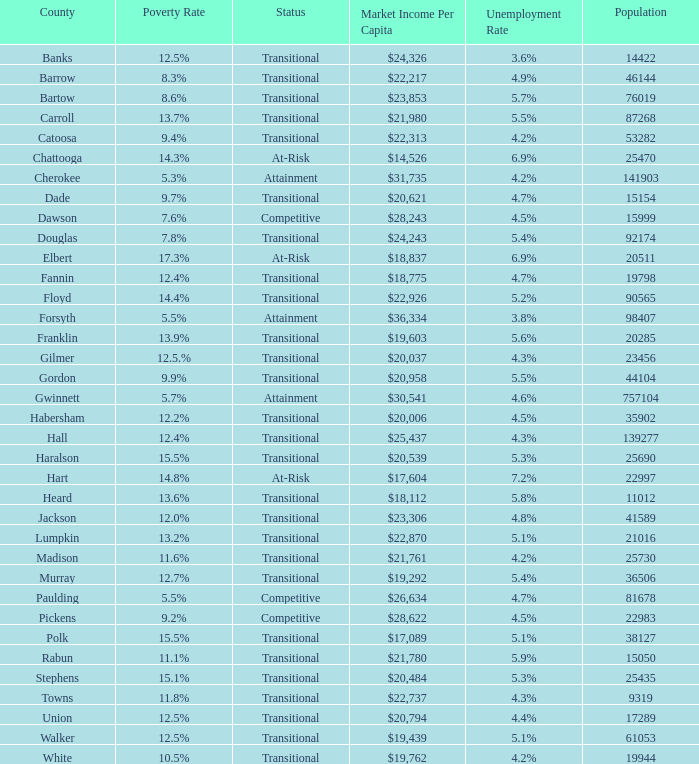What is the unemployment rate for the county with a market income per capita of $20,958? 1.0. 